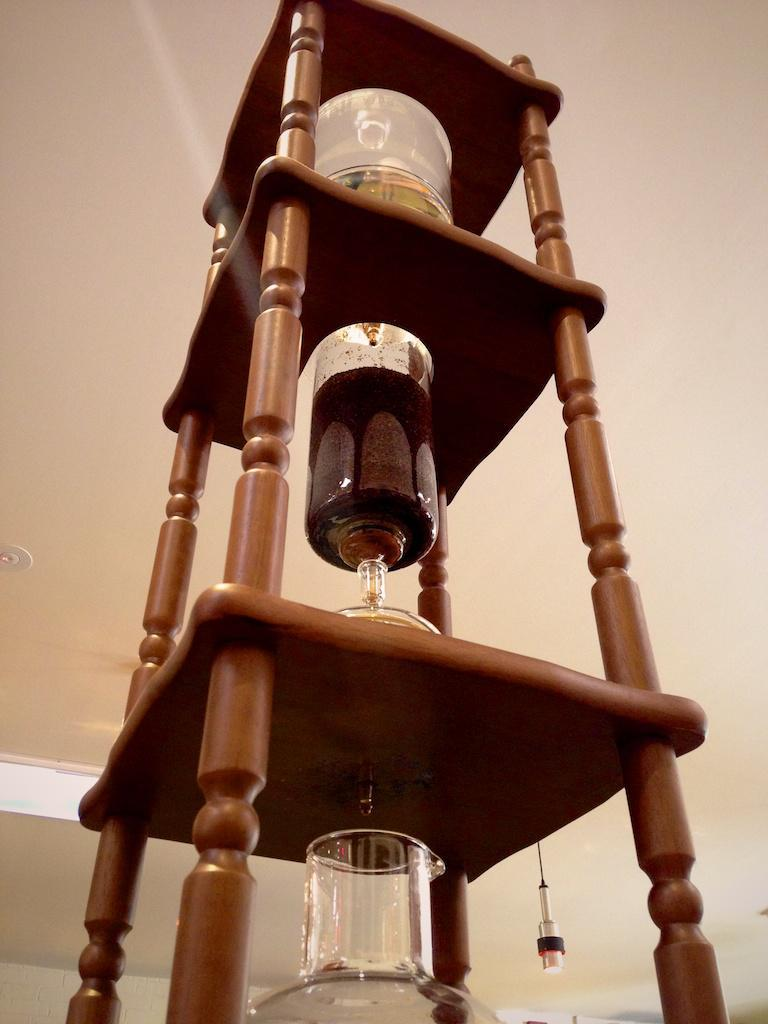What is the main structure in the image? There is a wooden stand with three racks in the image. What items can be seen on the stand? There are different items like glass, a box, and a bottle on the stand. What can be seen in the background of the image? There is a ceiling visible in the background of the image. What is attached to the ceiling? A light is hanged on the ceiling. Where is the scarecrow placed in the image? There is no scarecrow present in the image. What direction is the light pointing in the image? The provided facts do not specify the direction in which the light is pointing. 